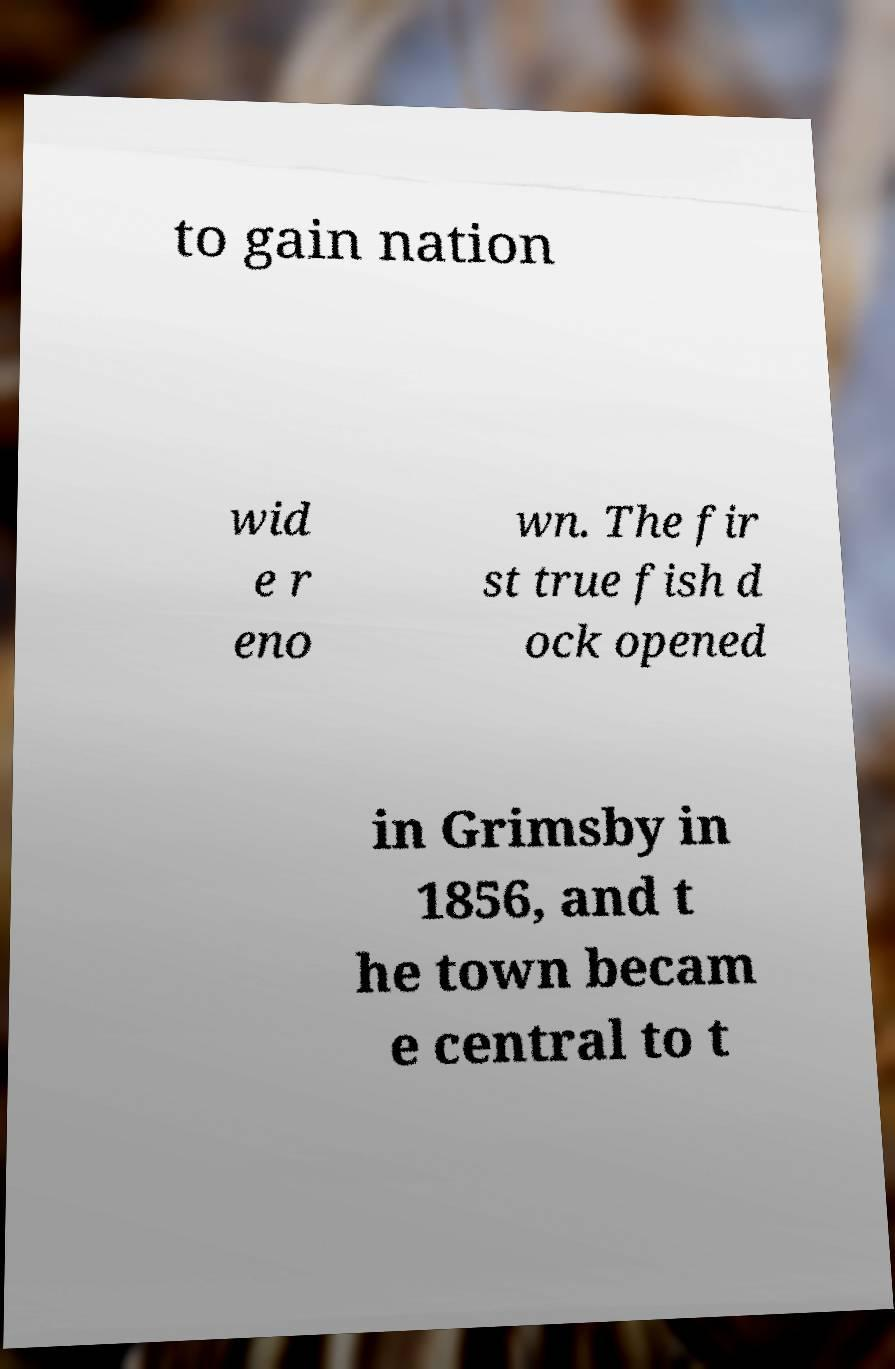For documentation purposes, I need the text within this image transcribed. Could you provide that? to gain nation wid e r eno wn. The fir st true fish d ock opened in Grimsby in 1856, and t he town becam e central to t 